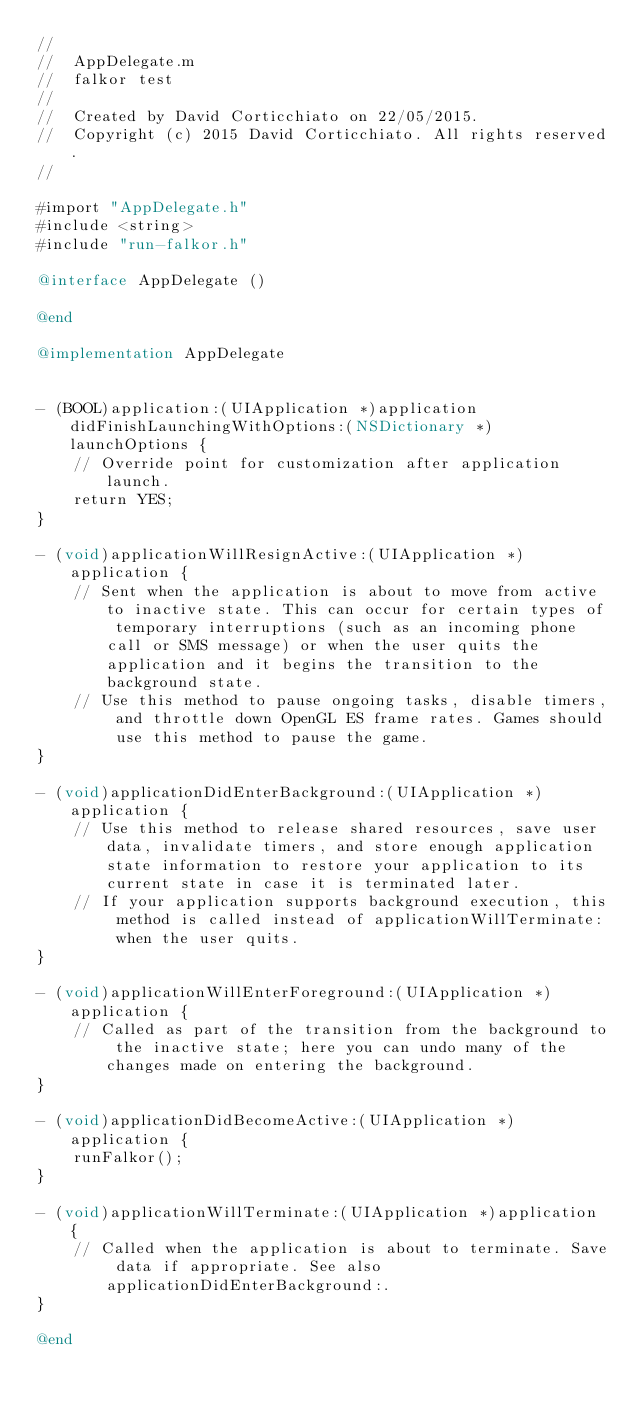<code> <loc_0><loc_0><loc_500><loc_500><_ObjectiveC_>//
//  AppDelegate.m
//  falkor test
//
//  Created by David Corticchiato on 22/05/2015.
//  Copyright (c) 2015 David Corticchiato. All rights reserved.
//

#import "AppDelegate.h"
#include <string>
#include "run-falkor.h"

@interface AppDelegate ()

@end

@implementation AppDelegate


- (BOOL)application:(UIApplication *)application didFinishLaunchingWithOptions:(NSDictionary *)launchOptions {
    // Override point for customization after application launch.
    return YES;
}

- (void)applicationWillResignActive:(UIApplication *)application {
    // Sent when the application is about to move from active to inactive state. This can occur for certain types of temporary interruptions (such as an incoming phone call or SMS message) or when the user quits the application and it begins the transition to the background state.
    // Use this method to pause ongoing tasks, disable timers, and throttle down OpenGL ES frame rates. Games should use this method to pause the game.
}

- (void)applicationDidEnterBackground:(UIApplication *)application {
    // Use this method to release shared resources, save user data, invalidate timers, and store enough application state information to restore your application to its current state in case it is terminated later.
    // If your application supports background execution, this method is called instead of applicationWillTerminate: when the user quits.
}

- (void)applicationWillEnterForeground:(UIApplication *)application {
    // Called as part of the transition from the background to the inactive state; here you can undo many of the changes made on entering the background.
}

- (void)applicationDidBecomeActive:(UIApplication *)application {
    runFalkor();
}

- (void)applicationWillTerminate:(UIApplication *)application {
    // Called when the application is about to terminate. Save data if appropriate. See also applicationDidEnterBackground:.
}

@end
</code> 